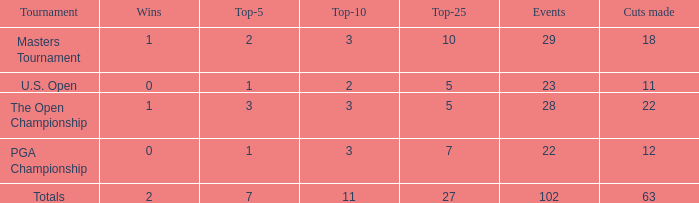What is the number of vuts for a player who has 2 victories and less than 7 top 5 finishes? None. 